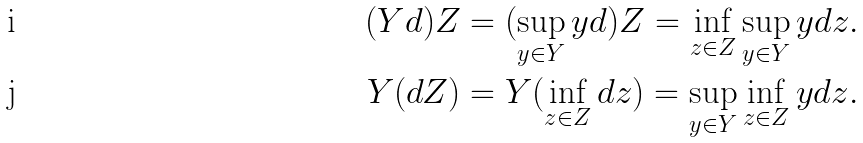Convert formula to latex. <formula><loc_0><loc_0><loc_500><loc_500>( Y d ) Z & = ( \sup _ { y \in Y } y d ) Z = \inf _ { z \in Z } \sup _ { y \in Y } y d z . \\ Y ( d Z ) & = Y ( \inf _ { z \in Z } d z ) = \sup _ { y \in Y } \inf _ { z \in Z } y d z .</formula> 